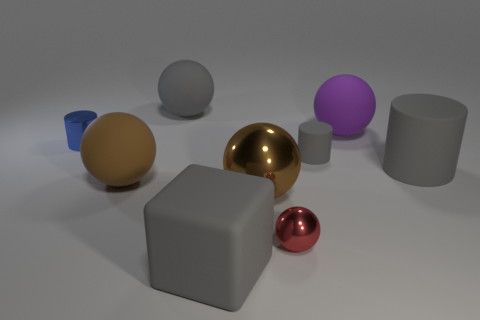Subtract all tiny spheres. How many spheres are left? 4 Add 1 small yellow things. How many objects exist? 10 Subtract all balls. How many objects are left? 4 Subtract all purple cylinders. How many brown spheres are left? 2 Subtract all gray cylinders. How many cylinders are left? 1 Subtract 3 cylinders. How many cylinders are left? 0 Add 6 red shiny spheres. How many red shiny spheres are left? 7 Add 3 big red balls. How many big red balls exist? 3 Subtract 0 red cubes. How many objects are left? 9 Subtract all purple spheres. Subtract all yellow blocks. How many spheres are left? 4 